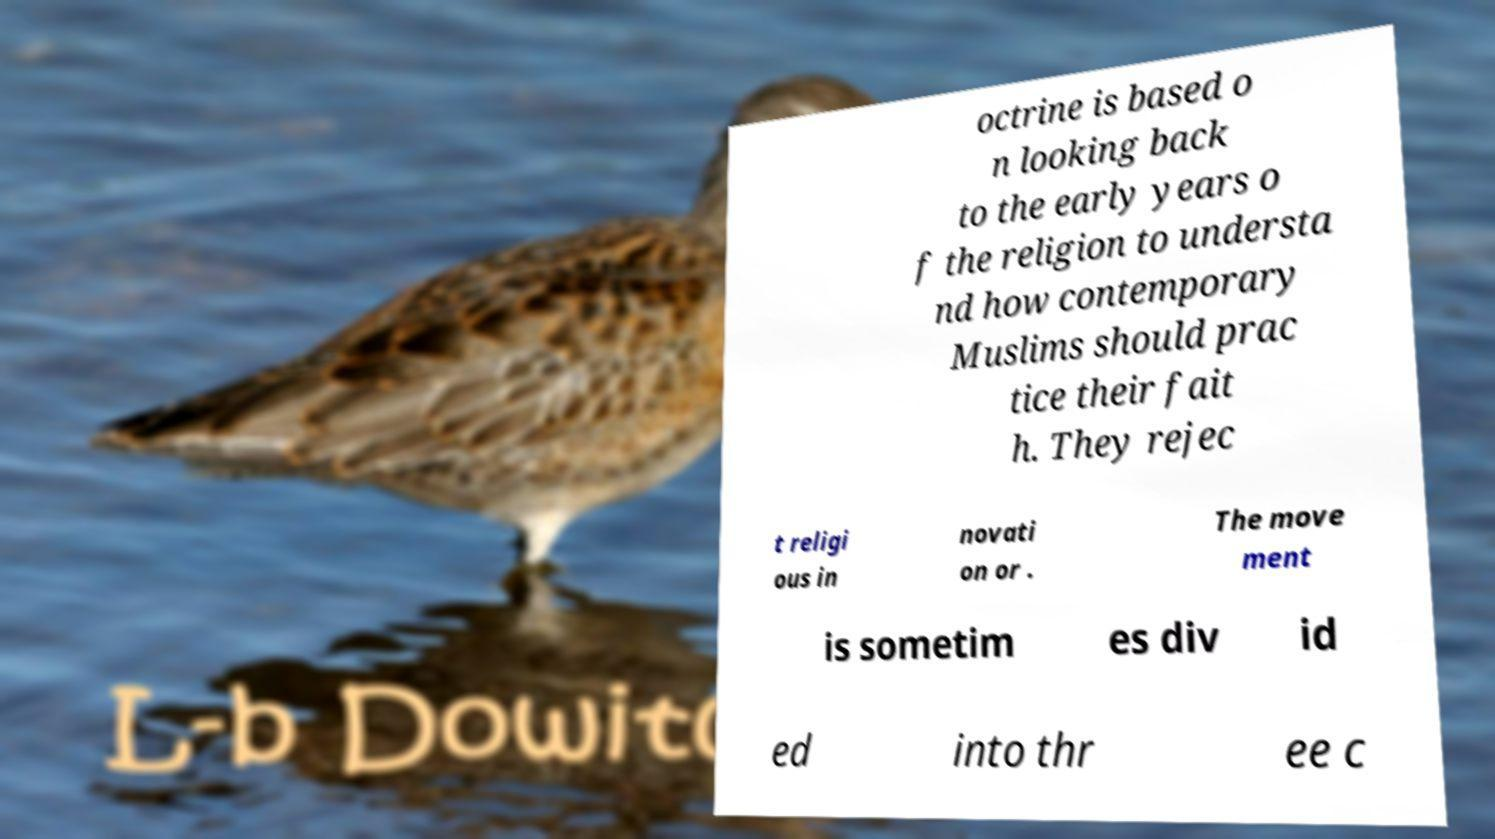Please read and relay the text visible in this image. What does it say? octrine is based o n looking back to the early years o f the religion to understa nd how contemporary Muslims should prac tice their fait h. They rejec t religi ous in novati on or . The move ment is sometim es div id ed into thr ee c 